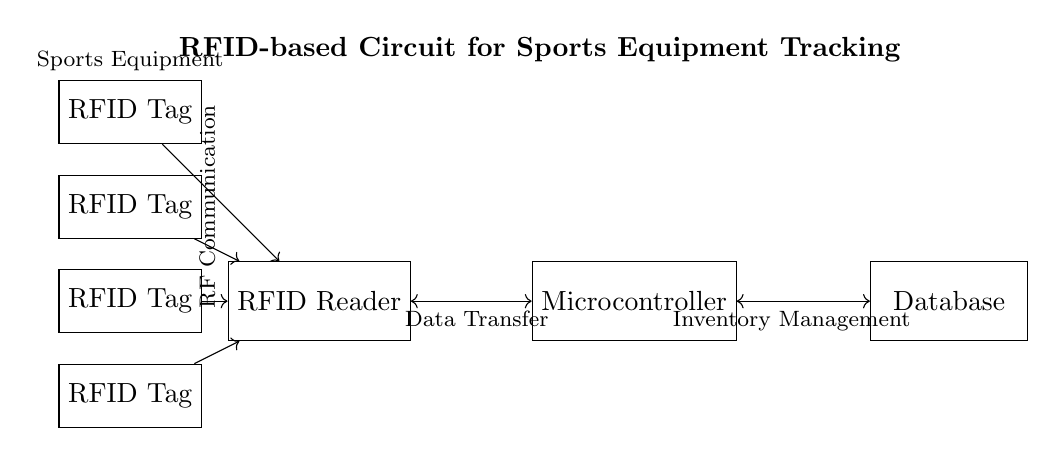What is the main component of this circuit? The main component, as depicted in the diagram, is the RFID Reader, which is responsible for detecting RFID tags.
Answer: RFID Reader How many RFID tags are connected to the reader? The diagram shows four RFID tags connected to the reader, indicated by the four rectangles labeled as RFID Tag.
Answer: Four What type of communication is used between components? The circuit indicates RF Communication, which is a common method used for wireless communication in RFID technology.
Answer: RF Communication What is the purpose of the microcontroller in this circuit? The microcontroller serves as the processing unit that manages data coming from the RFID Reader and interacts with the database for inventory management.
Answer: Data management Explain the relationship between the RFID Reader and the microcontroller. The RFID Reader receives signals from the RFID tags and sends the data to the microcontroller; they are connected bidirectionally as shown by the two-way arrows.
Answer: Bidirectional data transfer What is the function of the database in this circuit? The database stores all inventory information and data related to sports equipment, which is managed by the microcontroller after receiving input from the RFID Reader.
Answer: Inventory data storage What does the label ‘Data Transfer’ indicate regarding circuit functionality? The 'Data Transfer' label signifies that there is a flow of information from the RFID Reader to the microcontroller for processing, which is essential for managing the equipment's status and location.
Answer: Information flow 